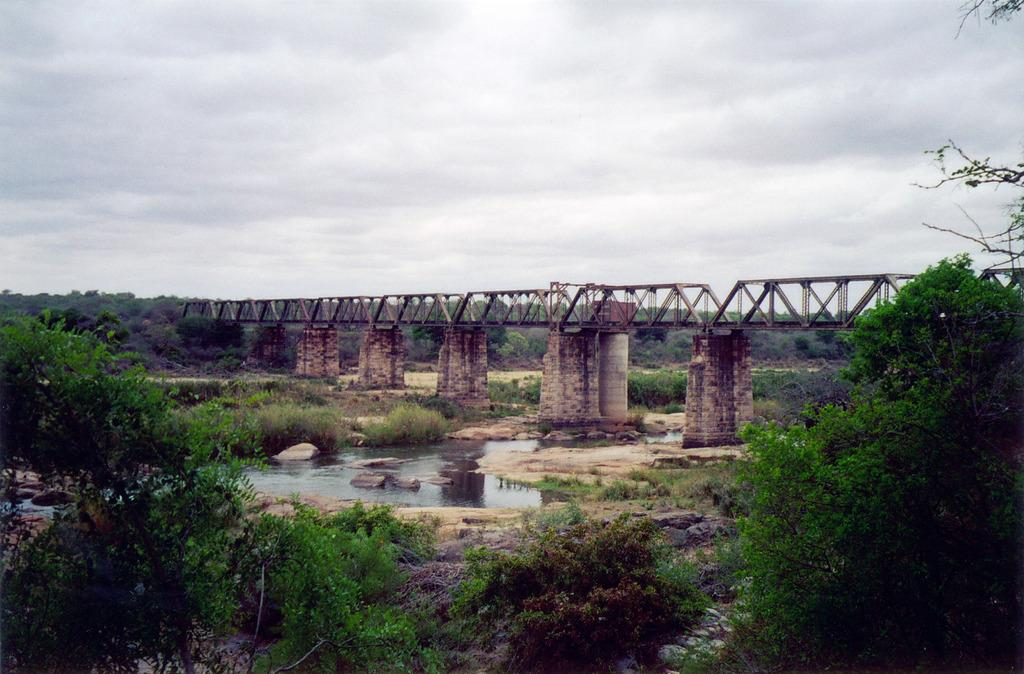What structure is located in the middle of the image? There is a bridge in the middle of the image. What is located below the bridge? There is a pond below the bridge. What can be seen around the pond? The pond is surrounded by plants. What type of vegetation is present in the image? Trees are present in the image. What is visible at the top of the image? The sky is visible in the image, and clouds are present in the sky. What type of bird can be seen carrying a pail in the image? There is no bird carrying a pail present in the image. 